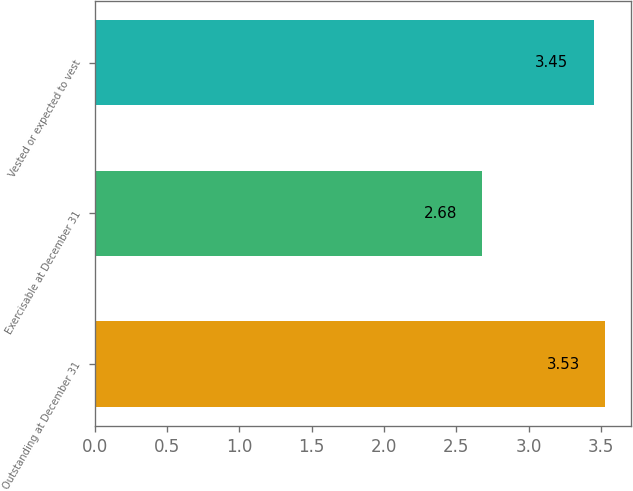Convert chart. <chart><loc_0><loc_0><loc_500><loc_500><bar_chart><fcel>Outstanding at December 31<fcel>Exercisable at December 31<fcel>Vested or expected to vest<nl><fcel>3.53<fcel>2.68<fcel>3.45<nl></chart> 